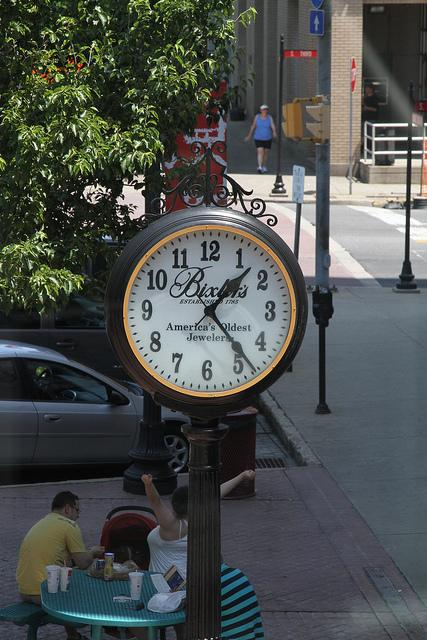What is the highest number that is visible? twelve 